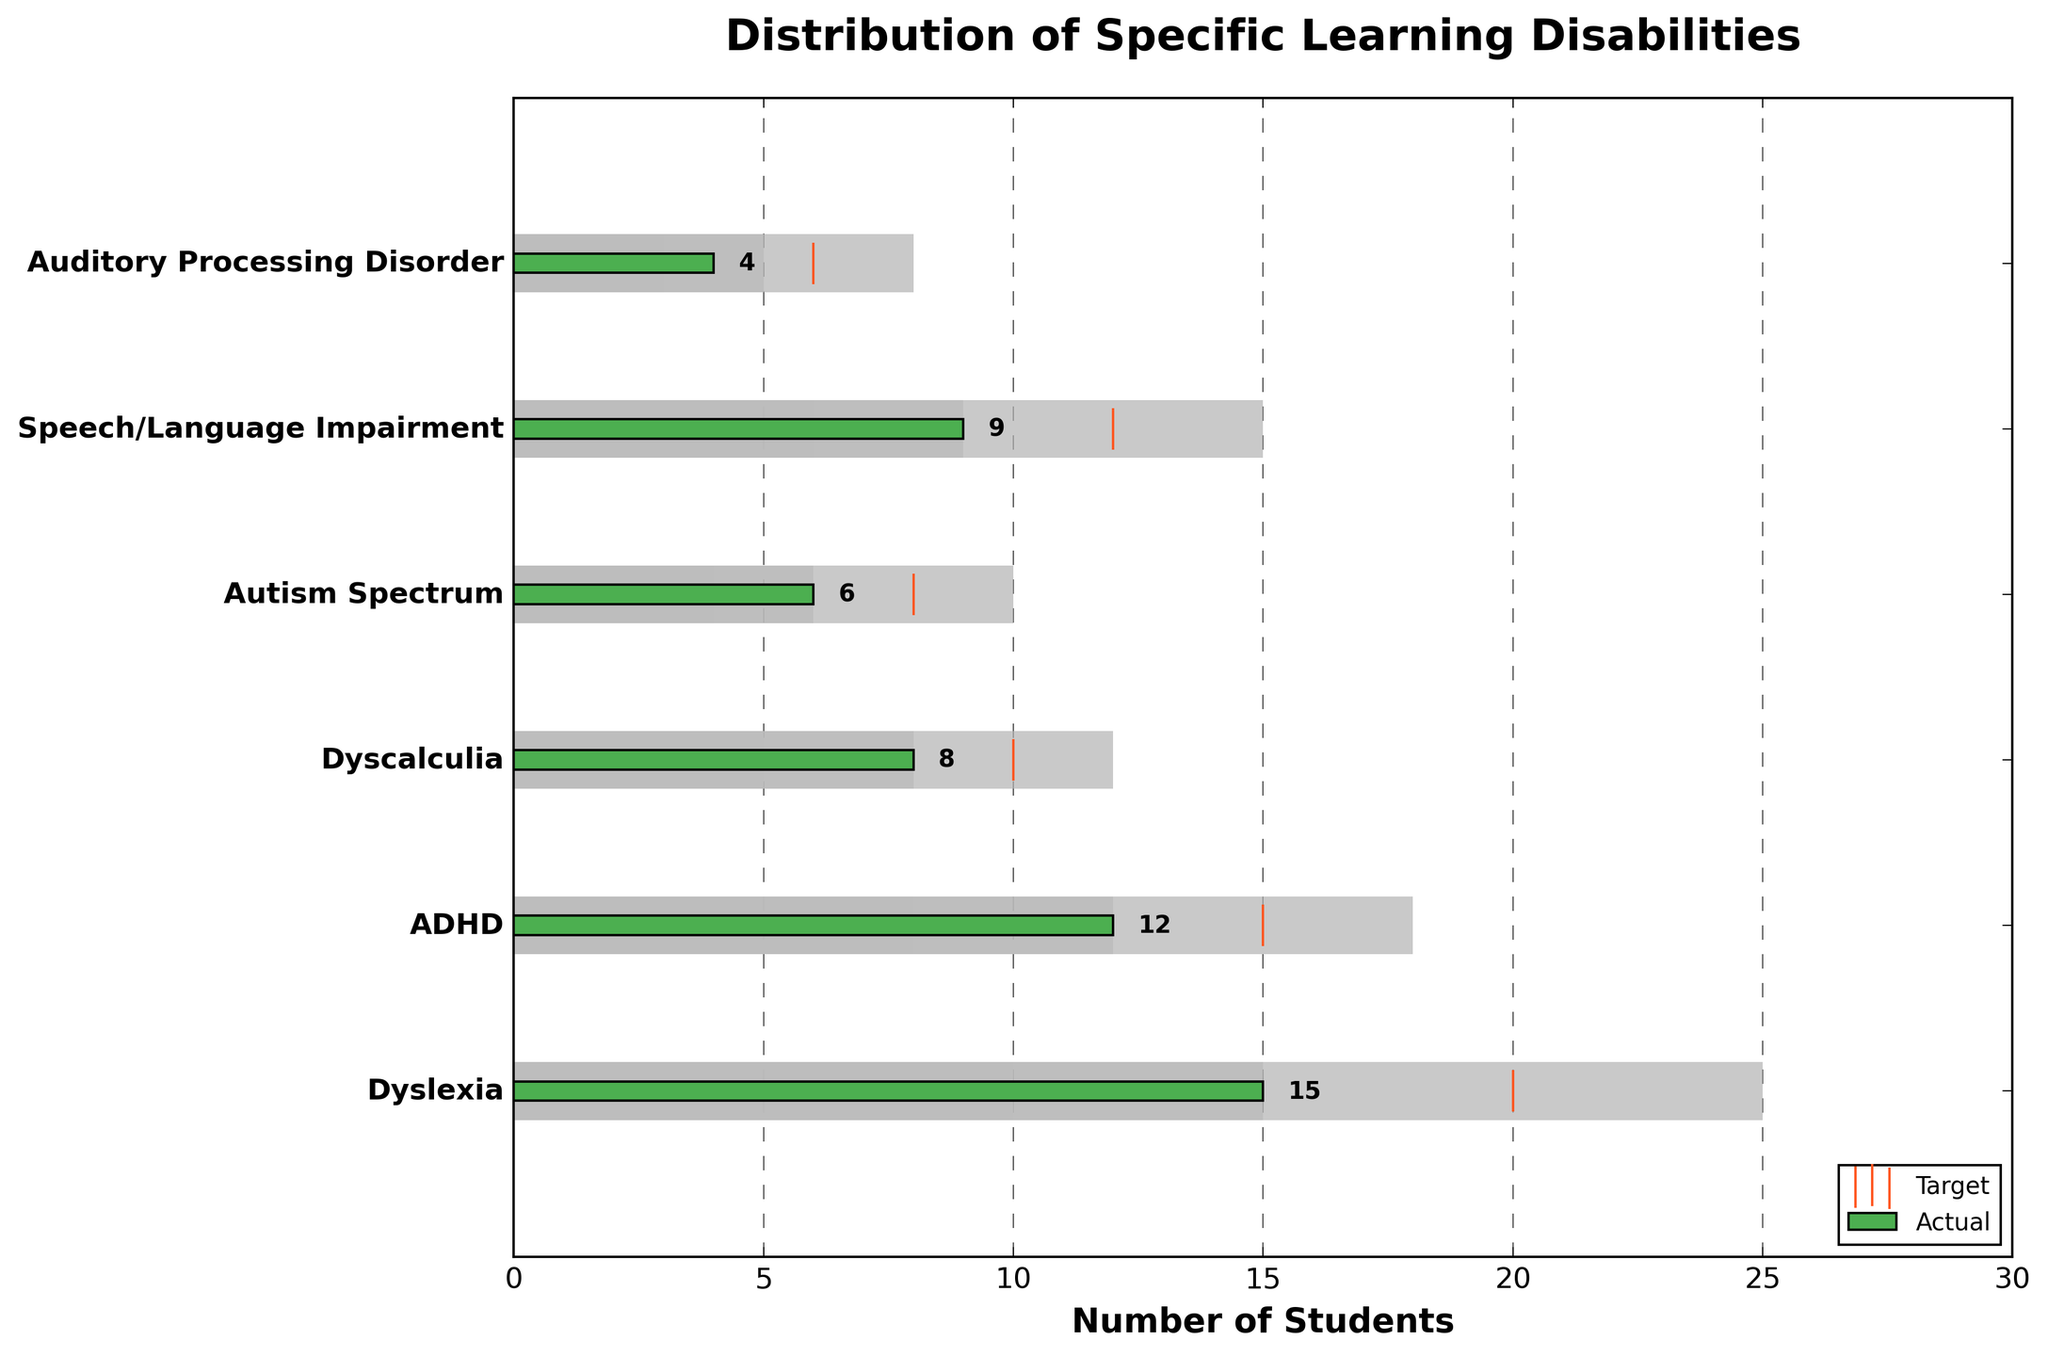What's the total number of students with Dyslexia represented in the chart? Refer to the "Actual" value for Dyslexia, which is the green bar.
Answer: 15 Which specific learning disability has the highest target number of students? Compare the target values (orange markers) for each disability. Speech/Language Impairment has the highest target at 12.
Answer: Speech/Language Impairment How does the actual number of students with ADHD compare to its target? The actual value for ADHD is 12 and the target value is 15, so the actual number is less than the target.
Answer: Less than What's the difference between the actual and target number of students for Autism Spectrum? The actual number is 6 and the target is 8. The difference is calculated as 8 - 6.
Answer: 2 Which specific learning disability has the smallest range between Range1 and Range3? Calculate the range (Range3 - Range1) for each disability. Autism Spectrum has the smallest range with 10 - 4 = 6.
Answer: Autism Spectrum Is the actual number of students with Dyscalculia within its target range? The actual value for Dyscalculia is 8 which falls within the range of 5 to 12.
Answer: Yes What is the sum of the actual number of students for all disabilities? Sum the actual values for each category: 15 + 12 + 8 + 6 + 9 + 4 = 54.
Answer: 54 According to the chart, which specific learning disability is closest to meeting its target? Calculate the difference between actual and target for each category. Dyslexia is closest with a difference of 5 (20 - 15).
Answer: Dyslexia What's the average target number of students across all disabilities? Sum the target values and divide by the number of categories: (20 + 15 + 10 + 8 + 12 + 6) / 6 = 71 / 6 ≈ 11.83.
Answer: Around 11.83 Which specific learning disability has the largest discrepancy between its actual and target number? Calculate the absolute difference for each category. Dyslexia has the largest discrepancy with a difference of 5.
Answer: Dyslexia 